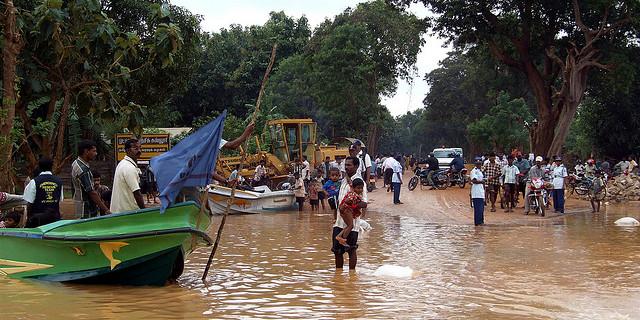What are the people standing in?
Answer briefly. Water. What color is the water?
Write a very short answer. Brown. What color are the people?
Keep it brief. Brown. 